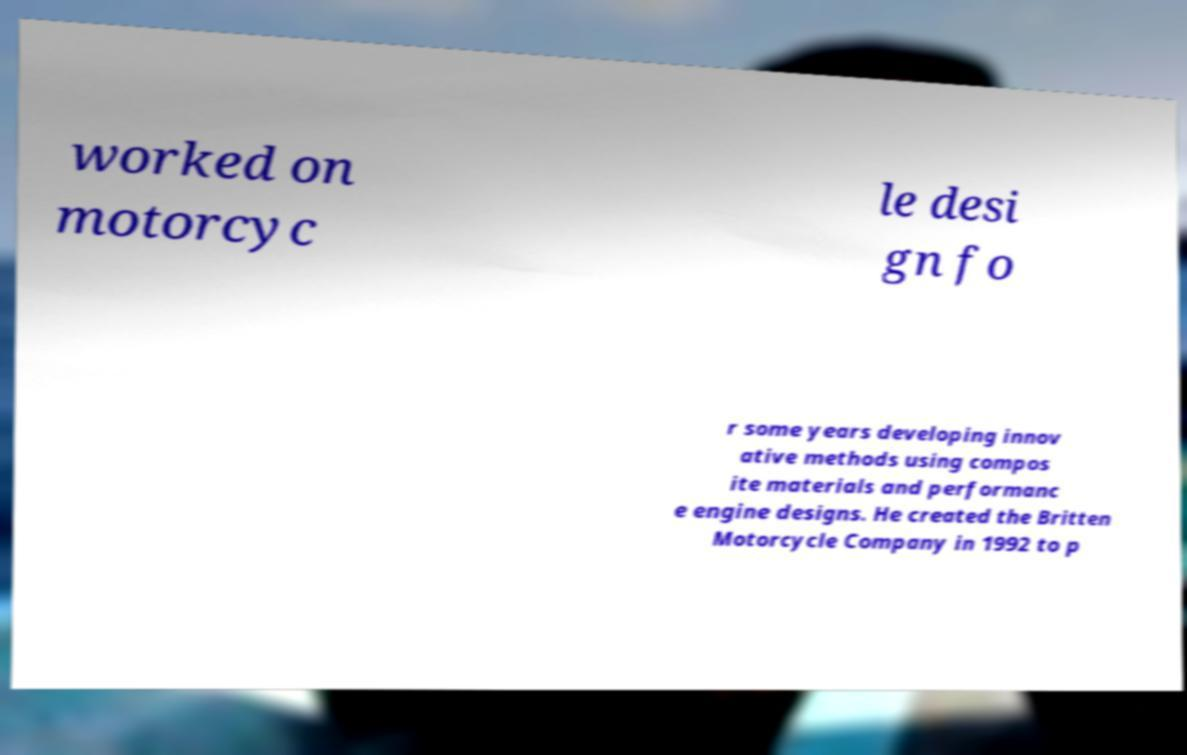Please read and relay the text visible in this image. What does it say? worked on motorcyc le desi gn fo r some years developing innov ative methods using compos ite materials and performanc e engine designs. He created the Britten Motorcycle Company in 1992 to p 